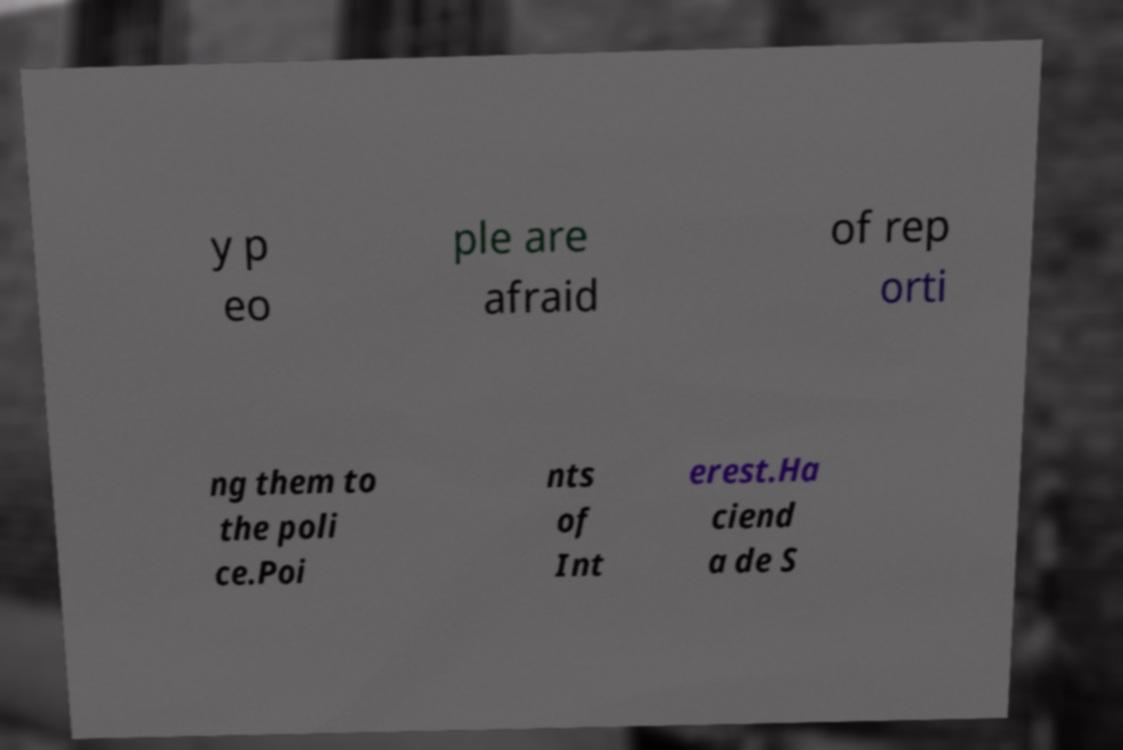Please read and relay the text visible in this image. What does it say? y p eo ple are afraid of rep orti ng them to the poli ce.Poi nts of Int erest.Ha ciend a de S 